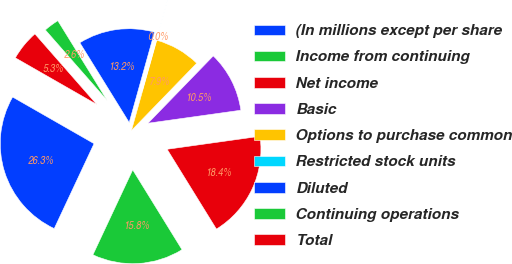Convert chart to OTSL. <chart><loc_0><loc_0><loc_500><loc_500><pie_chart><fcel>(In millions except per share<fcel>Income from continuing<fcel>Net income<fcel>Basic<fcel>Options to purchase common<fcel>Restricted stock units<fcel>Diluted<fcel>Continuing operations<fcel>Total<nl><fcel>26.3%<fcel>15.78%<fcel>18.41%<fcel>10.53%<fcel>7.9%<fcel>0.01%<fcel>13.16%<fcel>2.64%<fcel>5.27%<nl></chart> 